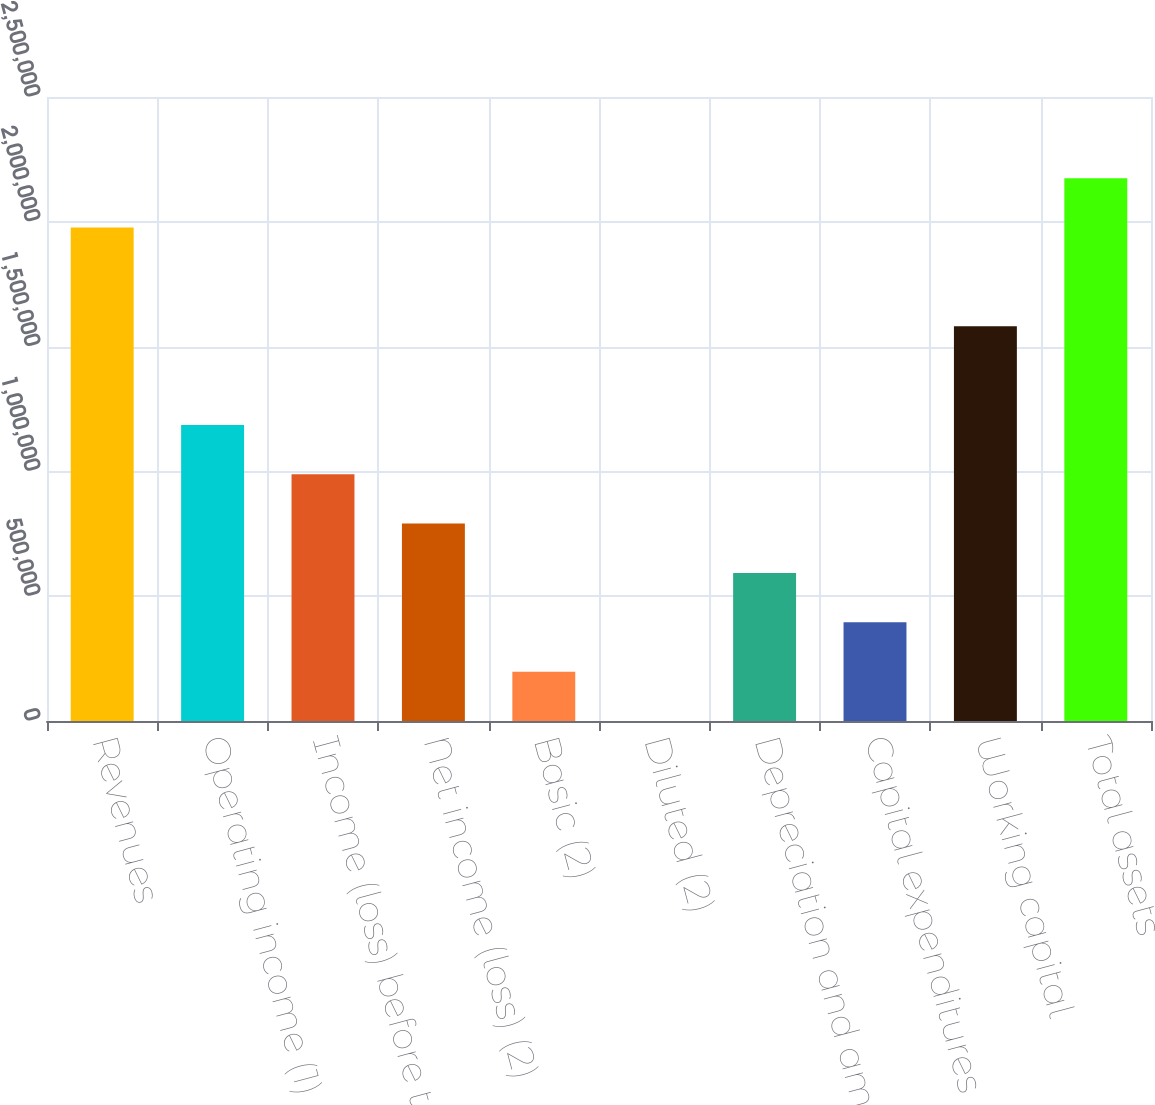Convert chart. <chart><loc_0><loc_0><loc_500><loc_500><bar_chart><fcel>Revenues<fcel>Operating income (1) (4)<fcel>Income (loss) before taxes (4)<fcel>Net income (loss) (2)<fcel>Basic (2)<fcel>Diluted (2)<fcel>Depreciation and amortization<fcel>Capital expenditures<fcel>Working capital<fcel>Total assets<nl><fcel>1.97723e+06<fcel>1.18634e+06<fcel>988614<fcel>790892<fcel>197724<fcel>0.89<fcel>593169<fcel>395446<fcel>1.58178e+06<fcel>2.17495e+06<nl></chart> 